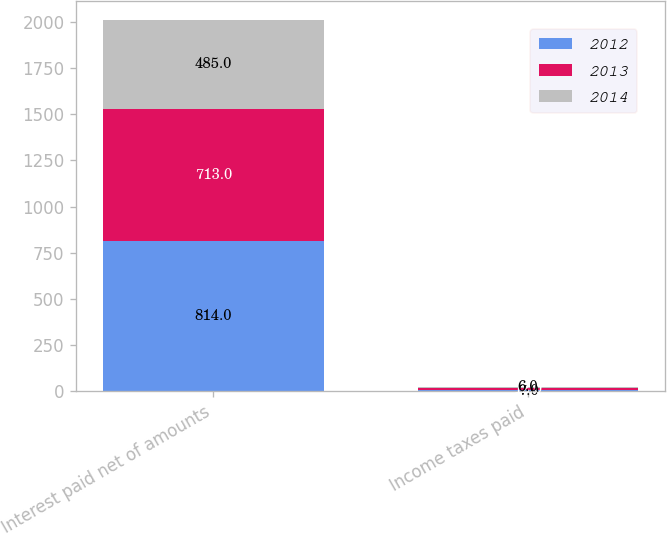Convert chart to OTSL. <chart><loc_0><loc_0><loc_500><loc_500><stacked_bar_chart><ecel><fcel>Interest paid net of amounts<fcel>Income taxes paid<nl><fcel>2012<fcel>814<fcel>7<nl><fcel>2013<fcel>713<fcel>12<nl><fcel>2014<fcel>485<fcel>6<nl></chart> 